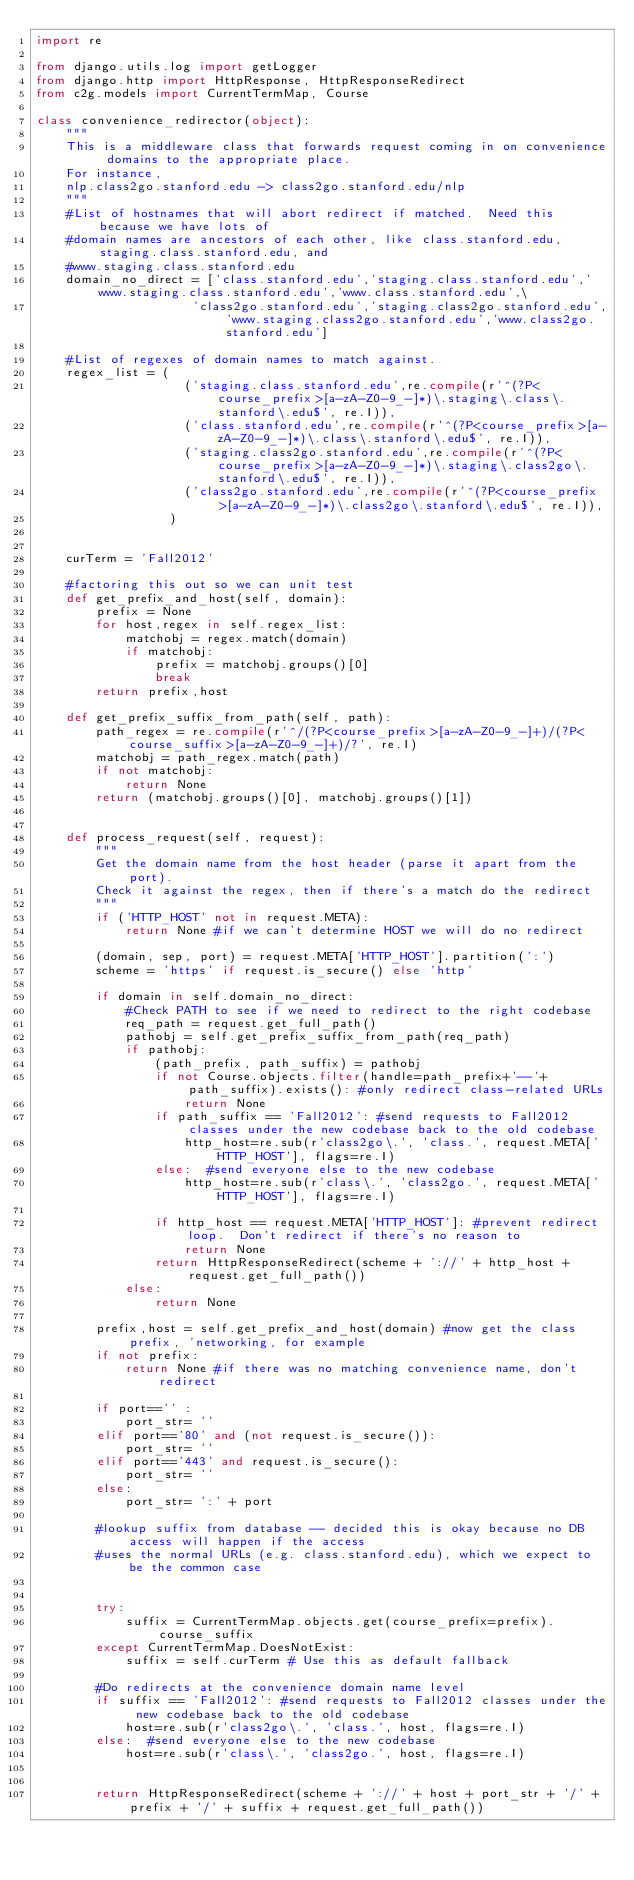Convert code to text. <code><loc_0><loc_0><loc_500><loc_500><_Python_>import re

from django.utils.log import getLogger
from django.http import HttpResponse, HttpResponseRedirect
from c2g.models import CurrentTermMap, Course

class convenience_redirector(object):
    """
    This is a middleware class that forwards request coming in on convenience domains to the appropriate place.
    For instance, 
    nlp.class2go.stanford.edu -> class2go.stanford.edu/nlp
    """
    #List of hostnames that will abort redirect if matched.  Need this because we have lots of
    #domain names are ancestors of each other, like class.stanford.edu, staging.class.stanford.edu, and
    #www.staging.class.stanford.edu
    domain_no_direct = ['class.stanford.edu','staging.class.stanford.edu','www.staging.class.stanford.edu','www.class.stanford.edu',\
                     'class2go.stanford.edu','staging.class2go.stanford.edu','www.staging.class2go.stanford.edu','www.class2go.stanford.edu']
    
    #List of regexes of domain names to match against. 
    regex_list = (
                    ('staging.class.stanford.edu',re.compile(r'^(?P<course_prefix>[a-zA-Z0-9_-]*)\.staging\.class\.stanford\.edu$', re.I)),
                    ('class.stanford.edu',re.compile(r'^(?P<course_prefix>[a-zA-Z0-9_-]*)\.class\.stanford\.edu$', re.I)),
                    ('staging.class2go.stanford.edu',re.compile(r'^(?P<course_prefix>[a-zA-Z0-9_-]*)\.staging\.class2go\.stanford\.edu$', re.I)),
                    ('class2go.stanford.edu',re.compile(r'^(?P<course_prefix>[a-zA-Z0-9_-]*)\.class2go\.stanford\.edu$', re.I)),
                  )
    
    
    curTerm = 'Fall2012'
    
    #factoring this out so we can unit test
    def get_prefix_and_host(self, domain):
        prefix = None
        for host,regex in self.regex_list:
            matchobj = regex.match(domain)
            if matchobj:
                prefix = matchobj.groups()[0]
                break
        return prefix,host

    def get_prefix_suffix_from_path(self, path):
        path_regex = re.compile(r'^/(?P<course_prefix>[a-zA-Z0-9_-]+)/(?P<course_suffix>[a-zA-Z0-9_-]+)/?', re.I)
        matchobj = path_regex.match(path)
        if not matchobj:
            return None
        return (matchobj.groups()[0], matchobj.groups()[1])


    def process_request(self, request):
        """
        Get the domain name from the host header (parse it apart from the port).
        Check it against the regex, then if there's a match do the redirect
        """
        if ('HTTP_HOST' not in request.META):
            return None #if we can't determine HOST we will do no redirect
        
        (domain, sep, port) = request.META['HTTP_HOST'].partition(':')
        scheme = 'https' if request.is_secure() else 'http'

        if domain in self.domain_no_direct:
            #Check PATH to see if we need to redirect to the right codebase
            req_path = request.get_full_path()
            pathobj = self.get_prefix_suffix_from_path(req_path)
            if pathobj:
                (path_prefix, path_suffix) = pathobj
                if not Course.objects.filter(handle=path_prefix+'--'+path_suffix).exists(): #only redirect class-related URLs
                    return None
                if path_suffix == 'Fall2012': #send requests to Fall2012 classes under the new codebase back to the old codebase
                    http_host=re.sub(r'class2go\.', 'class.', request.META['HTTP_HOST'], flags=re.I)
                else:  #send everyone else to the new codebase
                    http_host=re.sub(r'class\.', 'class2go.', request.META['HTTP_HOST'], flags=re.I)
            
                if http_host == request.META['HTTP_HOST']: #prevent redirect loop.  Don't redirect if there's no reason to
                    return None
                return HttpResponseRedirect(scheme + '://' + http_host + request.get_full_path())
            else:
                return None
        
        prefix,host = self.get_prefix_and_host(domain) #now get the class prefix, 'networking, for example
        if not prefix:
            return None #if there was no matching convenience name, don't redirect
            
        if port=='' :
            port_str= ''
        elif port=='80' and (not request.is_secure()):
            port_str= ''
        elif port=='443' and request.is_secure():
            port_str= ''
        else:
            port_str= ':' + port

        #lookup suffix from database -- decided this is okay because no DB access will happen if the access
        #uses the normal URLs (e.g. class.stanford.edu), which we expect to be the common case
                
                
        try:
            suffix = CurrentTermMap.objects.get(course_prefix=prefix).course_suffix
        except CurrentTermMap.DoesNotExist:
            suffix = self.curTerm # Use this as default fallback

        #Do redirects at the convenience domain name level
        if suffix == 'Fall2012': #send requests to Fall2012 classes under the new codebase back to the old codebase
            host=re.sub(r'class2go\.', 'class.', host, flags=re.I)
        else:  #send everyone else to the new codebase
            host=re.sub(r'class\.', 'class2go.', host, flags=re.I)


        return HttpResponseRedirect(scheme + '://' + host + port_str + '/' + prefix + '/' + suffix + request.get_full_path())
        
            
        
</code> 